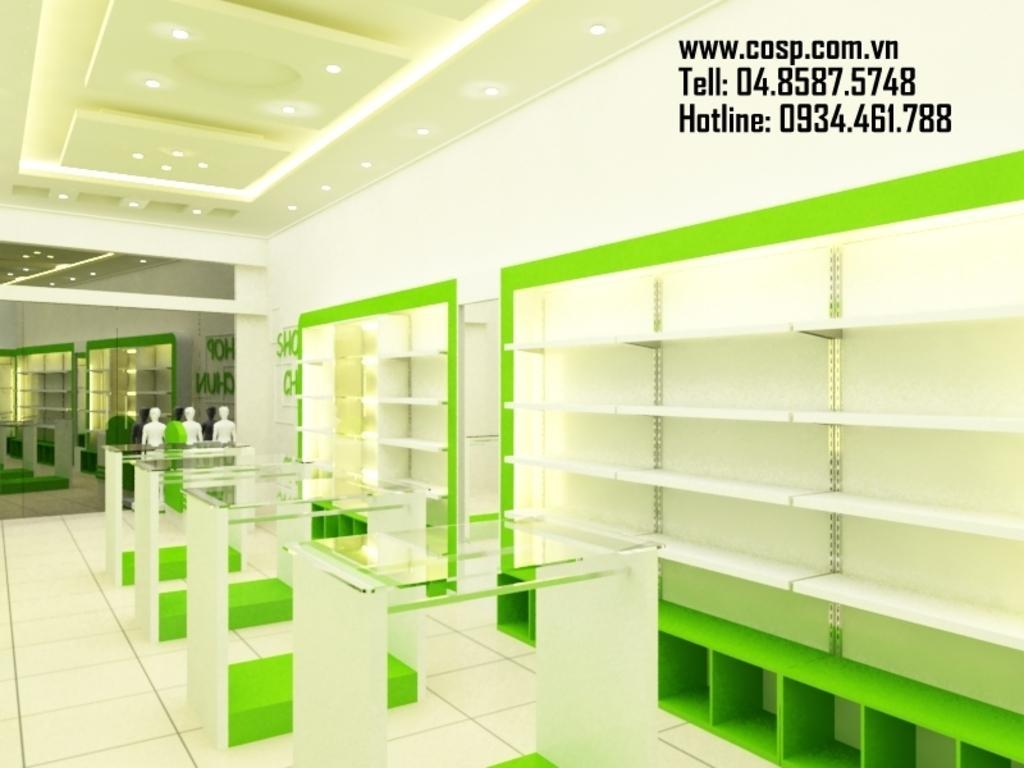Can you describe this image briefly? In this picture I can see the racks. I can see the glass desks. I can see light arrangements on the roof. I can see three mannequins on the left side. I can see the mirror in the background. 